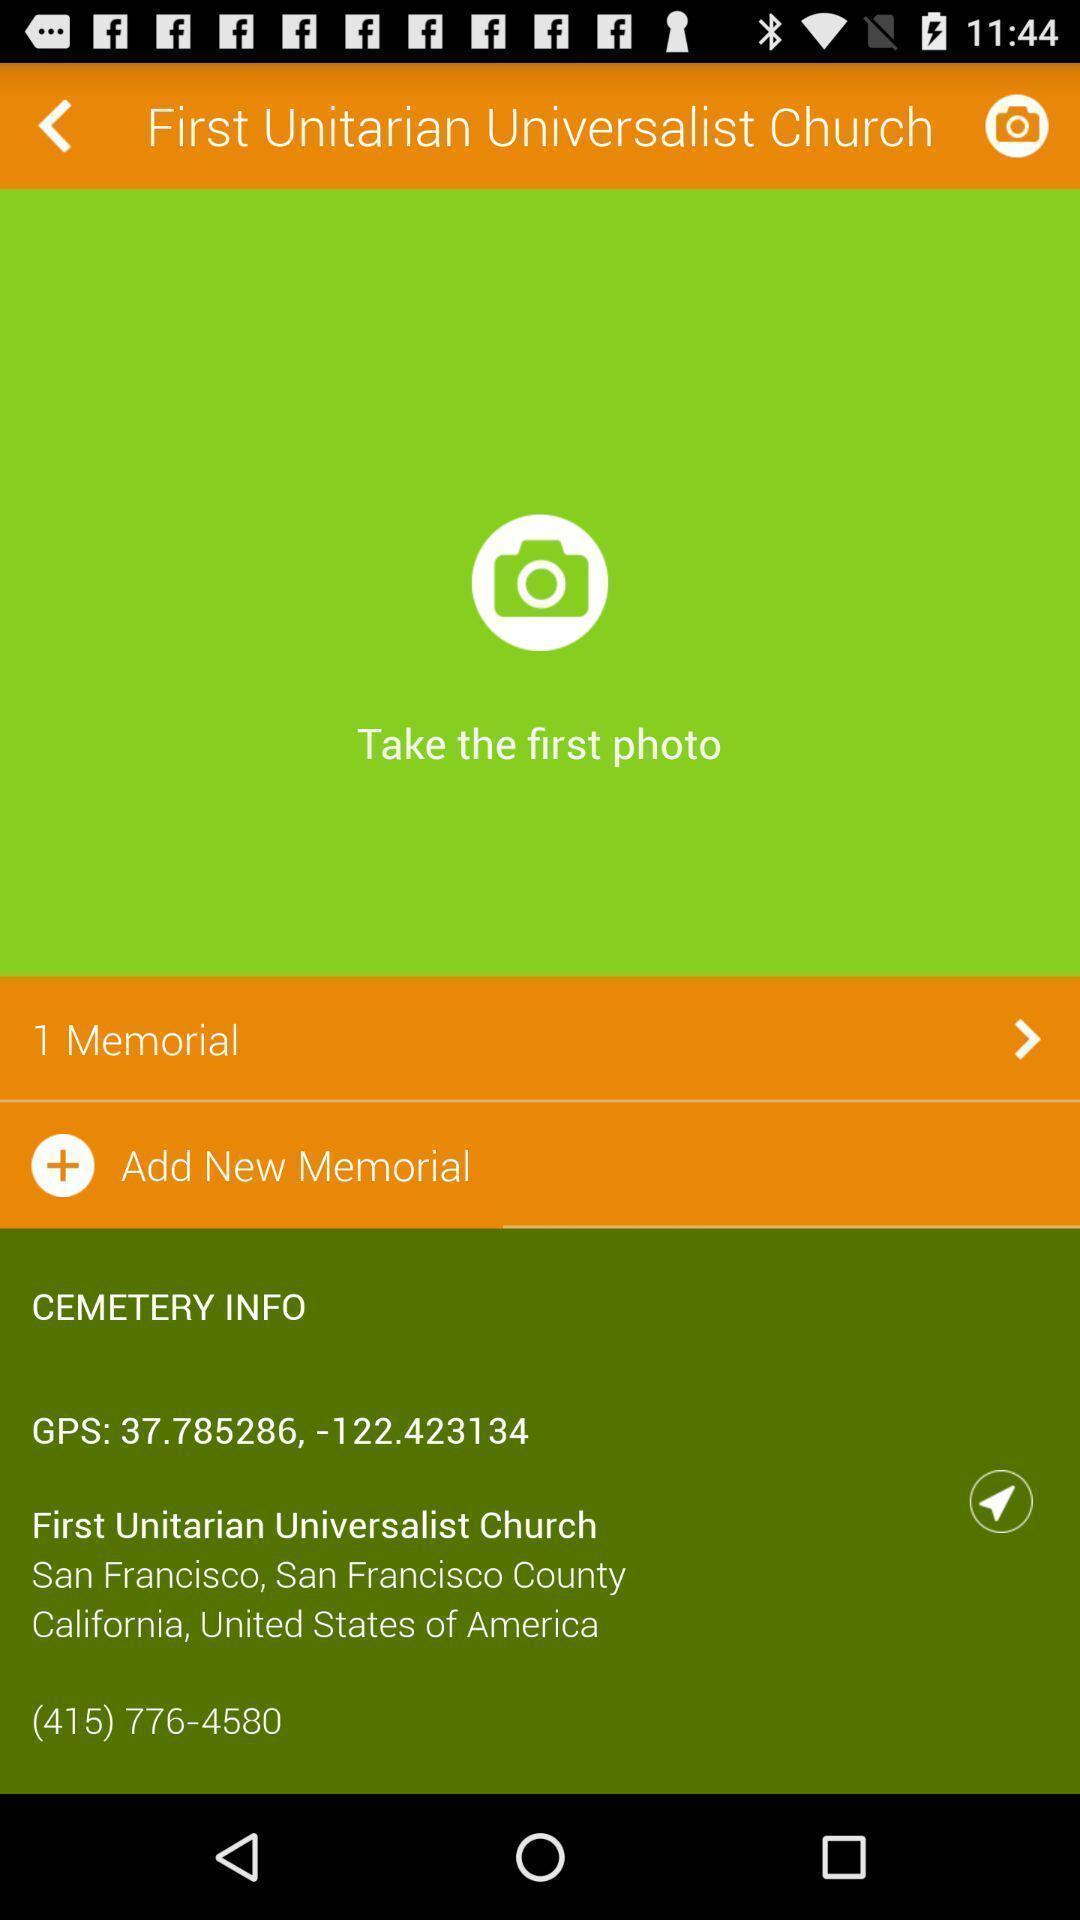Describe the key features of this screenshot. Screen shows to take photo option in a devotional app. 